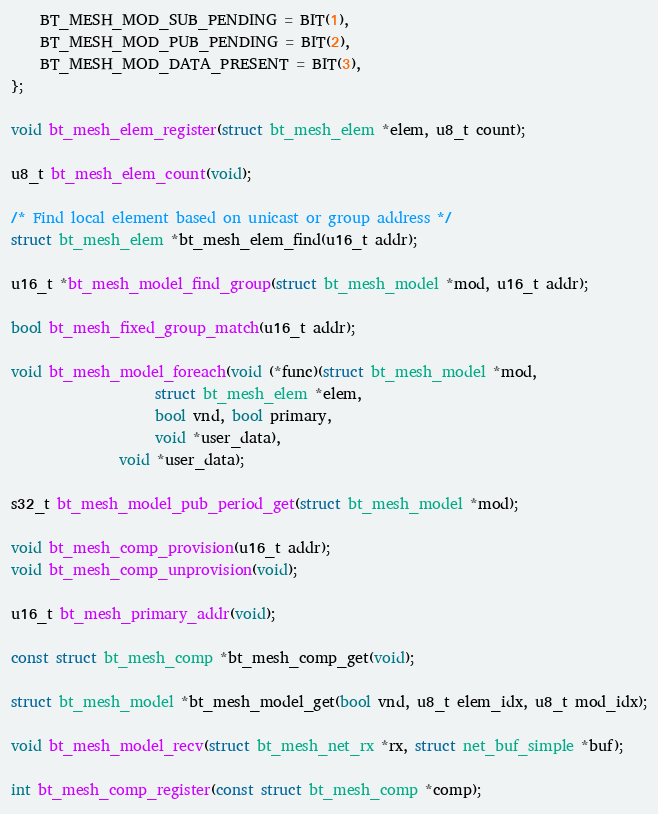Convert code to text. <code><loc_0><loc_0><loc_500><loc_500><_C_>	BT_MESH_MOD_SUB_PENDING = BIT(1),
	BT_MESH_MOD_PUB_PENDING = BIT(2),
	BT_MESH_MOD_DATA_PRESENT = BIT(3),
};

void bt_mesh_elem_register(struct bt_mesh_elem *elem, u8_t count);

u8_t bt_mesh_elem_count(void);

/* Find local element based on unicast or group address */
struct bt_mesh_elem *bt_mesh_elem_find(u16_t addr);

u16_t *bt_mesh_model_find_group(struct bt_mesh_model *mod, u16_t addr);

bool bt_mesh_fixed_group_match(u16_t addr);

void bt_mesh_model_foreach(void (*func)(struct bt_mesh_model *mod,
					struct bt_mesh_elem *elem,
					bool vnd, bool primary,
					void *user_data),
			   void *user_data);

s32_t bt_mesh_model_pub_period_get(struct bt_mesh_model *mod);

void bt_mesh_comp_provision(u16_t addr);
void bt_mesh_comp_unprovision(void);

u16_t bt_mesh_primary_addr(void);

const struct bt_mesh_comp *bt_mesh_comp_get(void);

struct bt_mesh_model *bt_mesh_model_get(bool vnd, u8_t elem_idx, u8_t mod_idx);

void bt_mesh_model_recv(struct bt_mesh_net_rx *rx, struct net_buf_simple *buf);

int bt_mesh_comp_register(const struct bt_mesh_comp *comp);
</code> 